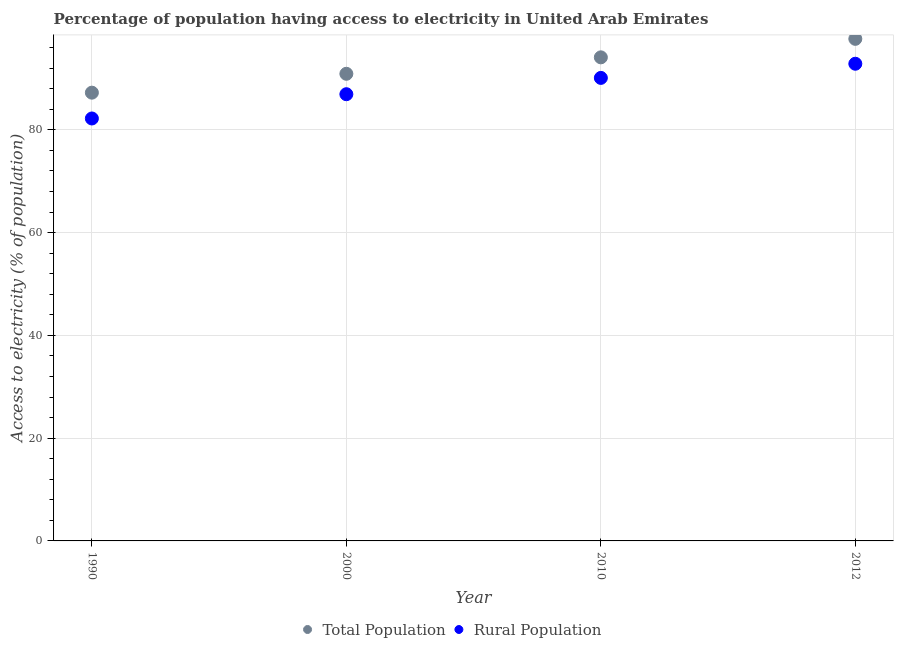Is the number of dotlines equal to the number of legend labels?
Offer a very short reply. Yes. What is the percentage of population having access to electricity in 2010?
Provide a short and direct response. 94.1. Across all years, what is the maximum percentage of population having access to electricity?
Offer a terse response. 97.7. Across all years, what is the minimum percentage of rural population having access to electricity?
Your response must be concise. 82.2. In which year was the percentage of population having access to electricity maximum?
Offer a very short reply. 2012. What is the total percentage of rural population having access to electricity in the graph?
Offer a very short reply. 352.08. What is the difference between the percentage of rural population having access to electricity in 1990 and that in 2010?
Offer a very short reply. -7.9. What is the difference between the percentage of population having access to electricity in 2012 and the percentage of rural population having access to electricity in 2000?
Your answer should be compact. 10.77. What is the average percentage of population having access to electricity per year?
Give a very brief answer. 92.48. In the year 2000, what is the difference between the percentage of population having access to electricity and percentage of rural population having access to electricity?
Provide a succinct answer. 3.97. What is the ratio of the percentage of population having access to electricity in 1990 to that in 2010?
Your answer should be very brief. 0.93. What is the difference between the highest and the second highest percentage of population having access to electricity?
Ensure brevity in your answer.  3.6. What is the difference between the highest and the lowest percentage of rural population having access to electricity?
Offer a terse response. 10.65. Is the sum of the percentage of population having access to electricity in 1990 and 2012 greater than the maximum percentage of rural population having access to electricity across all years?
Give a very brief answer. Yes. Is the percentage of rural population having access to electricity strictly greater than the percentage of population having access to electricity over the years?
Ensure brevity in your answer.  No. Is the percentage of rural population having access to electricity strictly less than the percentage of population having access to electricity over the years?
Offer a terse response. Yes. How many dotlines are there?
Your answer should be compact. 2. Are the values on the major ticks of Y-axis written in scientific E-notation?
Keep it short and to the point. No. Does the graph contain any zero values?
Offer a very short reply. No. Does the graph contain grids?
Provide a succinct answer. Yes. Where does the legend appear in the graph?
Offer a very short reply. Bottom center. What is the title of the graph?
Keep it short and to the point. Percentage of population having access to electricity in United Arab Emirates. What is the label or title of the X-axis?
Keep it short and to the point. Year. What is the label or title of the Y-axis?
Ensure brevity in your answer.  Access to electricity (% of population). What is the Access to electricity (% of population) of Total Population in 1990?
Provide a short and direct response. 87.23. What is the Access to electricity (% of population) in Rural Population in 1990?
Your answer should be compact. 82.2. What is the Access to electricity (% of population) of Total Population in 2000?
Your response must be concise. 90.9. What is the Access to electricity (% of population) of Rural Population in 2000?
Your answer should be compact. 86.93. What is the Access to electricity (% of population) of Total Population in 2010?
Give a very brief answer. 94.1. What is the Access to electricity (% of population) in Rural Population in 2010?
Ensure brevity in your answer.  90.1. What is the Access to electricity (% of population) in Total Population in 2012?
Give a very brief answer. 97.7. What is the Access to electricity (% of population) in Rural Population in 2012?
Ensure brevity in your answer.  92.85. Across all years, what is the maximum Access to electricity (% of population) of Total Population?
Your response must be concise. 97.7. Across all years, what is the maximum Access to electricity (% of population) of Rural Population?
Ensure brevity in your answer.  92.85. Across all years, what is the minimum Access to electricity (% of population) of Total Population?
Give a very brief answer. 87.23. Across all years, what is the minimum Access to electricity (% of population) of Rural Population?
Offer a very short reply. 82.2. What is the total Access to electricity (% of population) of Total Population in the graph?
Your answer should be very brief. 369.92. What is the total Access to electricity (% of population) in Rural Population in the graph?
Provide a succinct answer. 352.08. What is the difference between the Access to electricity (% of population) in Total Population in 1990 and that in 2000?
Your response must be concise. -3.67. What is the difference between the Access to electricity (% of population) in Rural Population in 1990 and that in 2000?
Your answer should be very brief. -4.72. What is the difference between the Access to electricity (% of population) of Total Population in 1990 and that in 2010?
Make the answer very short. -6.87. What is the difference between the Access to electricity (% of population) of Rural Population in 1990 and that in 2010?
Ensure brevity in your answer.  -7.9. What is the difference between the Access to electricity (% of population) of Total Population in 1990 and that in 2012?
Provide a succinct answer. -10.47. What is the difference between the Access to electricity (% of population) of Rural Population in 1990 and that in 2012?
Offer a very short reply. -10.65. What is the difference between the Access to electricity (% of population) of Total Population in 2000 and that in 2010?
Provide a succinct answer. -3.2. What is the difference between the Access to electricity (% of population) of Rural Population in 2000 and that in 2010?
Offer a very short reply. -3.17. What is the difference between the Access to electricity (% of population) in Total Population in 2000 and that in 2012?
Give a very brief answer. -6.8. What is the difference between the Access to electricity (% of population) of Rural Population in 2000 and that in 2012?
Your answer should be compact. -5.93. What is the difference between the Access to electricity (% of population) of Total Population in 2010 and that in 2012?
Provide a succinct answer. -3.6. What is the difference between the Access to electricity (% of population) in Rural Population in 2010 and that in 2012?
Provide a short and direct response. -2.75. What is the difference between the Access to electricity (% of population) in Total Population in 1990 and the Access to electricity (% of population) in Rural Population in 2000?
Offer a terse response. 0.3. What is the difference between the Access to electricity (% of population) of Total Population in 1990 and the Access to electricity (% of population) of Rural Population in 2010?
Provide a short and direct response. -2.87. What is the difference between the Access to electricity (% of population) in Total Population in 1990 and the Access to electricity (% of population) in Rural Population in 2012?
Provide a short and direct response. -5.63. What is the difference between the Access to electricity (% of population) of Total Population in 2000 and the Access to electricity (% of population) of Rural Population in 2010?
Offer a terse response. 0.8. What is the difference between the Access to electricity (% of population) in Total Population in 2000 and the Access to electricity (% of population) in Rural Population in 2012?
Give a very brief answer. -1.96. What is the difference between the Access to electricity (% of population) of Total Population in 2010 and the Access to electricity (% of population) of Rural Population in 2012?
Your response must be concise. 1.25. What is the average Access to electricity (% of population) of Total Population per year?
Your answer should be very brief. 92.48. What is the average Access to electricity (% of population) in Rural Population per year?
Keep it short and to the point. 88.02. In the year 1990, what is the difference between the Access to electricity (% of population) in Total Population and Access to electricity (% of population) in Rural Population?
Provide a succinct answer. 5.02. In the year 2000, what is the difference between the Access to electricity (% of population) of Total Population and Access to electricity (% of population) of Rural Population?
Provide a short and direct response. 3.97. In the year 2012, what is the difference between the Access to electricity (% of population) in Total Population and Access to electricity (% of population) in Rural Population?
Ensure brevity in your answer.  4.84. What is the ratio of the Access to electricity (% of population) in Total Population in 1990 to that in 2000?
Give a very brief answer. 0.96. What is the ratio of the Access to electricity (% of population) in Rural Population in 1990 to that in 2000?
Provide a succinct answer. 0.95. What is the ratio of the Access to electricity (% of population) in Total Population in 1990 to that in 2010?
Keep it short and to the point. 0.93. What is the ratio of the Access to electricity (% of population) of Rural Population in 1990 to that in 2010?
Offer a very short reply. 0.91. What is the ratio of the Access to electricity (% of population) of Total Population in 1990 to that in 2012?
Provide a succinct answer. 0.89. What is the ratio of the Access to electricity (% of population) of Rural Population in 1990 to that in 2012?
Offer a terse response. 0.89. What is the ratio of the Access to electricity (% of population) in Rural Population in 2000 to that in 2010?
Ensure brevity in your answer.  0.96. What is the ratio of the Access to electricity (% of population) in Total Population in 2000 to that in 2012?
Offer a terse response. 0.93. What is the ratio of the Access to electricity (% of population) of Rural Population in 2000 to that in 2012?
Make the answer very short. 0.94. What is the ratio of the Access to electricity (% of population) in Total Population in 2010 to that in 2012?
Give a very brief answer. 0.96. What is the ratio of the Access to electricity (% of population) in Rural Population in 2010 to that in 2012?
Make the answer very short. 0.97. What is the difference between the highest and the second highest Access to electricity (% of population) in Total Population?
Keep it short and to the point. 3.6. What is the difference between the highest and the second highest Access to electricity (% of population) in Rural Population?
Make the answer very short. 2.75. What is the difference between the highest and the lowest Access to electricity (% of population) of Total Population?
Provide a short and direct response. 10.47. What is the difference between the highest and the lowest Access to electricity (% of population) of Rural Population?
Your answer should be very brief. 10.65. 